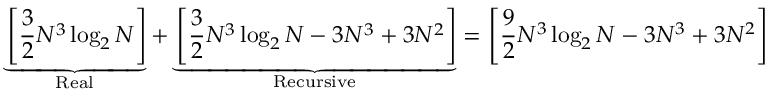<formula> <loc_0><loc_0><loc_500><loc_500>\underbrace { \left [ { \frac { 3 } { 2 } } N ^ { 3 } \log _ { 2 } N \right ] } _ { R e a l } + \underbrace { \left [ { \frac { 3 } { 2 } } N ^ { 3 } \log _ { 2 } N - 3 N ^ { 3 } + 3 N ^ { 2 } \right ] } _ { R e c u r s i v e } = \left [ { \frac { 9 } { 2 } } N ^ { 3 } \log _ { 2 } N - 3 N ^ { 3 } + 3 N ^ { 2 } \right ]</formula> 